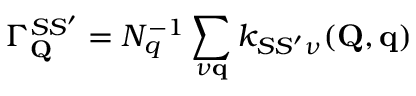<formula> <loc_0><loc_0><loc_500><loc_500>\Gamma _ { Q } ^ { S S ^ { \prime } } = N _ { q } ^ { - 1 } \sum _ { \nu q } k _ { S S ^ { \prime } \nu } ( Q , q )</formula> 